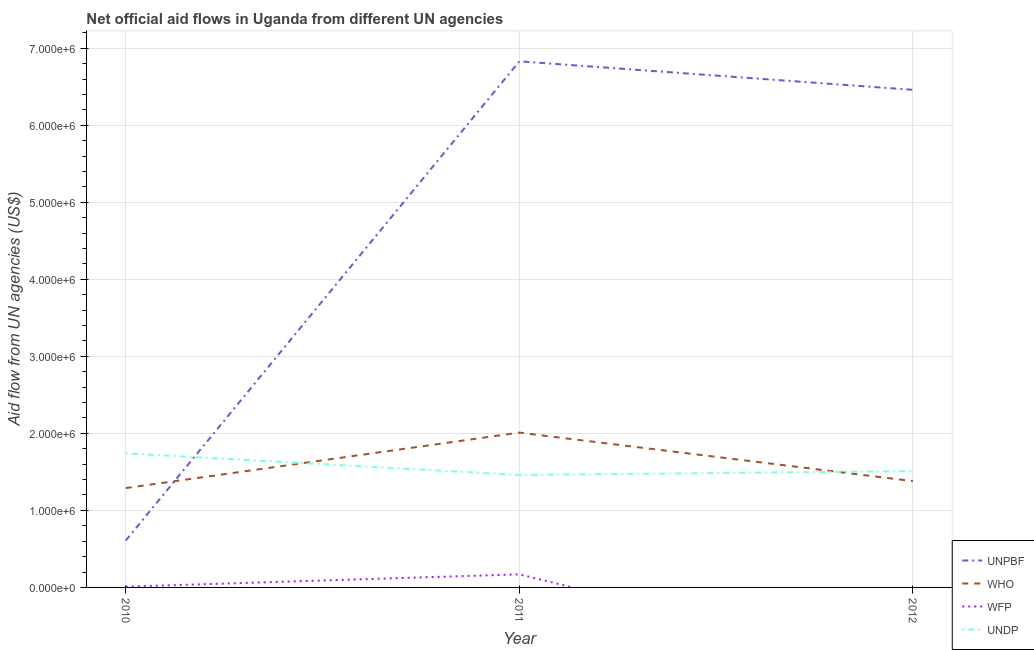How many different coloured lines are there?
Give a very brief answer. 4. Is the number of lines equal to the number of legend labels?
Give a very brief answer. No. What is the amount of aid given by unpbf in 2011?
Make the answer very short. 6.83e+06. Across all years, what is the maximum amount of aid given by wfp?
Your answer should be very brief. 1.70e+05. In which year was the amount of aid given by undp maximum?
Make the answer very short. 2010. What is the total amount of aid given by unpbf in the graph?
Give a very brief answer. 1.39e+07. What is the difference between the amount of aid given by wfp in 2010 and that in 2011?
Make the answer very short. -1.60e+05. What is the difference between the amount of aid given by who in 2011 and the amount of aid given by undp in 2010?
Your answer should be very brief. 2.70e+05. What is the average amount of aid given by unpbf per year?
Provide a succinct answer. 4.63e+06. In the year 2011, what is the difference between the amount of aid given by unpbf and amount of aid given by undp?
Provide a succinct answer. 5.37e+06. In how many years, is the amount of aid given by who greater than 5400000 US$?
Provide a short and direct response. 0. What is the ratio of the amount of aid given by unpbf in 2010 to that in 2011?
Your response must be concise. 0.09. Is the amount of aid given by who in 2011 less than that in 2012?
Offer a very short reply. No. Is the difference between the amount of aid given by who in 2010 and 2011 greater than the difference between the amount of aid given by unpbf in 2010 and 2011?
Your answer should be compact. Yes. What is the difference between the highest and the lowest amount of aid given by undp?
Keep it short and to the point. 2.80e+05. Is the sum of the amount of aid given by who in 2010 and 2012 greater than the maximum amount of aid given by undp across all years?
Offer a terse response. Yes. Is the amount of aid given by undp strictly greater than the amount of aid given by unpbf over the years?
Ensure brevity in your answer.  No. How many lines are there?
Ensure brevity in your answer.  4. How many years are there in the graph?
Your response must be concise. 3. What is the difference between two consecutive major ticks on the Y-axis?
Provide a succinct answer. 1.00e+06. Are the values on the major ticks of Y-axis written in scientific E-notation?
Provide a succinct answer. Yes. Does the graph contain any zero values?
Your response must be concise. Yes. Where does the legend appear in the graph?
Your answer should be compact. Bottom right. What is the title of the graph?
Ensure brevity in your answer.  Net official aid flows in Uganda from different UN agencies. Does "Italy" appear as one of the legend labels in the graph?
Offer a terse response. No. What is the label or title of the Y-axis?
Offer a terse response. Aid flow from UN agencies (US$). What is the Aid flow from UN agencies (US$) of UNPBF in 2010?
Your answer should be very brief. 6.10e+05. What is the Aid flow from UN agencies (US$) in WHO in 2010?
Give a very brief answer. 1.29e+06. What is the Aid flow from UN agencies (US$) in WFP in 2010?
Provide a succinct answer. 10000. What is the Aid flow from UN agencies (US$) of UNDP in 2010?
Give a very brief answer. 1.74e+06. What is the Aid flow from UN agencies (US$) in UNPBF in 2011?
Your answer should be very brief. 6.83e+06. What is the Aid flow from UN agencies (US$) of WHO in 2011?
Your answer should be compact. 2.01e+06. What is the Aid flow from UN agencies (US$) in WFP in 2011?
Ensure brevity in your answer.  1.70e+05. What is the Aid flow from UN agencies (US$) in UNDP in 2011?
Offer a very short reply. 1.46e+06. What is the Aid flow from UN agencies (US$) in UNPBF in 2012?
Offer a terse response. 6.46e+06. What is the Aid flow from UN agencies (US$) of WHO in 2012?
Give a very brief answer. 1.38e+06. What is the Aid flow from UN agencies (US$) of WFP in 2012?
Provide a succinct answer. 0. What is the Aid flow from UN agencies (US$) in UNDP in 2012?
Your answer should be compact. 1.51e+06. Across all years, what is the maximum Aid flow from UN agencies (US$) of UNPBF?
Offer a very short reply. 6.83e+06. Across all years, what is the maximum Aid flow from UN agencies (US$) in WHO?
Offer a very short reply. 2.01e+06. Across all years, what is the maximum Aid flow from UN agencies (US$) in WFP?
Offer a terse response. 1.70e+05. Across all years, what is the maximum Aid flow from UN agencies (US$) in UNDP?
Give a very brief answer. 1.74e+06. Across all years, what is the minimum Aid flow from UN agencies (US$) in UNPBF?
Make the answer very short. 6.10e+05. Across all years, what is the minimum Aid flow from UN agencies (US$) of WHO?
Offer a terse response. 1.29e+06. Across all years, what is the minimum Aid flow from UN agencies (US$) in WFP?
Your answer should be compact. 0. Across all years, what is the minimum Aid flow from UN agencies (US$) in UNDP?
Give a very brief answer. 1.46e+06. What is the total Aid flow from UN agencies (US$) of UNPBF in the graph?
Ensure brevity in your answer.  1.39e+07. What is the total Aid flow from UN agencies (US$) of WHO in the graph?
Give a very brief answer. 4.68e+06. What is the total Aid flow from UN agencies (US$) of WFP in the graph?
Offer a very short reply. 1.80e+05. What is the total Aid flow from UN agencies (US$) in UNDP in the graph?
Provide a succinct answer. 4.71e+06. What is the difference between the Aid flow from UN agencies (US$) of UNPBF in 2010 and that in 2011?
Give a very brief answer. -6.22e+06. What is the difference between the Aid flow from UN agencies (US$) of WHO in 2010 and that in 2011?
Provide a succinct answer. -7.20e+05. What is the difference between the Aid flow from UN agencies (US$) in UNDP in 2010 and that in 2011?
Make the answer very short. 2.80e+05. What is the difference between the Aid flow from UN agencies (US$) in UNPBF in 2010 and that in 2012?
Provide a succinct answer. -5.85e+06. What is the difference between the Aid flow from UN agencies (US$) in UNDP in 2010 and that in 2012?
Offer a terse response. 2.30e+05. What is the difference between the Aid flow from UN agencies (US$) in WHO in 2011 and that in 2012?
Offer a very short reply. 6.30e+05. What is the difference between the Aid flow from UN agencies (US$) of UNDP in 2011 and that in 2012?
Your answer should be compact. -5.00e+04. What is the difference between the Aid flow from UN agencies (US$) of UNPBF in 2010 and the Aid flow from UN agencies (US$) of WHO in 2011?
Your answer should be compact. -1.40e+06. What is the difference between the Aid flow from UN agencies (US$) of UNPBF in 2010 and the Aid flow from UN agencies (US$) of WFP in 2011?
Keep it short and to the point. 4.40e+05. What is the difference between the Aid flow from UN agencies (US$) in UNPBF in 2010 and the Aid flow from UN agencies (US$) in UNDP in 2011?
Your response must be concise. -8.50e+05. What is the difference between the Aid flow from UN agencies (US$) of WHO in 2010 and the Aid flow from UN agencies (US$) of WFP in 2011?
Your response must be concise. 1.12e+06. What is the difference between the Aid flow from UN agencies (US$) of WFP in 2010 and the Aid flow from UN agencies (US$) of UNDP in 2011?
Give a very brief answer. -1.45e+06. What is the difference between the Aid flow from UN agencies (US$) of UNPBF in 2010 and the Aid flow from UN agencies (US$) of WHO in 2012?
Provide a short and direct response. -7.70e+05. What is the difference between the Aid flow from UN agencies (US$) in UNPBF in 2010 and the Aid flow from UN agencies (US$) in UNDP in 2012?
Make the answer very short. -9.00e+05. What is the difference between the Aid flow from UN agencies (US$) of WFP in 2010 and the Aid flow from UN agencies (US$) of UNDP in 2012?
Offer a very short reply. -1.50e+06. What is the difference between the Aid flow from UN agencies (US$) in UNPBF in 2011 and the Aid flow from UN agencies (US$) in WHO in 2012?
Offer a very short reply. 5.45e+06. What is the difference between the Aid flow from UN agencies (US$) of UNPBF in 2011 and the Aid flow from UN agencies (US$) of UNDP in 2012?
Your answer should be very brief. 5.32e+06. What is the difference between the Aid flow from UN agencies (US$) of WFP in 2011 and the Aid flow from UN agencies (US$) of UNDP in 2012?
Your answer should be very brief. -1.34e+06. What is the average Aid flow from UN agencies (US$) of UNPBF per year?
Provide a short and direct response. 4.63e+06. What is the average Aid flow from UN agencies (US$) in WHO per year?
Your answer should be very brief. 1.56e+06. What is the average Aid flow from UN agencies (US$) of WFP per year?
Provide a succinct answer. 6.00e+04. What is the average Aid flow from UN agencies (US$) in UNDP per year?
Provide a short and direct response. 1.57e+06. In the year 2010, what is the difference between the Aid flow from UN agencies (US$) of UNPBF and Aid flow from UN agencies (US$) of WHO?
Provide a succinct answer. -6.80e+05. In the year 2010, what is the difference between the Aid flow from UN agencies (US$) in UNPBF and Aid flow from UN agencies (US$) in WFP?
Offer a terse response. 6.00e+05. In the year 2010, what is the difference between the Aid flow from UN agencies (US$) of UNPBF and Aid flow from UN agencies (US$) of UNDP?
Your answer should be compact. -1.13e+06. In the year 2010, what is the difference between the Aid flow from UN agencies (US$) of WHO and Aid flow from UN agencies (US$) of WFP?
Provide a short and direct response. 1.28e+06. In the year 2010, what is the difference between the Aid flow from UN agencies (US$) in WHO and Aid flow from UN agencies (US$) in UNDP?
Your answer should be very brief. -4.50e+05. In the year 2010, what is the difference between the Aid flow from UN agencies (US$) in WFP and Aid flow from UN agencies (US$) in UNDP?
Your response must be concise. -1.73e+06. In the year 2011, what is the difference between the Aid flow from UN agencies (US$) of UNPBF and Aid flow from UN agencies (US$) of WHO?
Your answer should be compact. 4.82e+06. In the year 2011, what is the difference between the Aid flow from UN agencies (US$) in UNPBF and Aid flow from UN agencies (US$) in WFP?
Offer a terse response. 6.66e+06. In the year 2011, what is the difference between the Aid flow from UN agencies (US$) in UNPBF and Aid flow from UN agencies (US$) in UNDP?
Your response must be concise. 5.37e+06. In the year 2011, what is the difference between the Aid flow from UN agencies (US$) in WHO and Aid flow from UN agencies (US$) in WFP?
Provide a short and direct response. 1.84e+06. In the year 2011, what is the difference between the Aid flow from UN agencies (US$) in WFP and Aid flow from UN agencies (US$) in UNDP?
Your response must be concise. -1.29e+06. In the year 2012, what is the difference between the Aid flow from UN agencies (US$) of UNPBF and Aid flow from UN agencies (US$) of WHO?
Give a very brief answer. 5.08e+06. In the year 2012, what is the difference between the Aid flow from UN agencies (US$) of UNPBF and Aid flow from UN agencies (US$) of UNDP?
Keep it short and to the point. 4.95e+06. What is the ratio of the Aid flow from UN agencies (US$) in UNPBF in 2010 to that in 2011?
Provide a short and direct response. 0.09. What is the ratio of the Aid flow from UN agencies (US$) in WHO in 2010 to that in 2011?
Provide a short and direct response. 0.64. What is the ratio of the Aid flow from UN agencies (US$) in WFP in 2010 to that in 2011?
Offer a terse response. 0.06. What is the ratio of the Aid flow from UN agencies (US$) of UNDP in 2010 to that in 2011?
Keep it short and to the point. 1.19. What is the ratio of the Aid flow from UN agencies (US$) in UNPBF in 2010 to that in 2012?
Provide a short and direct response. 0.09. What is the ratio of the Aid flow from UN agencies (US$) in WHO in 2010 to that in 2012?
Ensure brevity in your answer.  0.93. What is the ratio of the Aid flow from UN agencies (US$) in UNDP in 2010 to that in 2012?
Your answer should be very brief. 1.15. What is the ratio of the Aid flow from UN agencies (US$) of UNPBF in 2011 to that in 2012?
Your answer should be compact. 1.06. What is the ratio of the Aid flow from UN agencies (US$) of WHO in 2011 to that in 2012?
Ensure brevity in your answer.  1.46. What is the ratio of the Aid flow from UN agencies (US$) of UNDP in 2011 to that in 2012?
Keep it short and to the point. 0.97. What is the difference between the highest and the second highest Aid flow from UN agencies (US$) in WHO?
Provide a succinct answer. 6.30e+05. What is the difference between the highest and the second highest Aid flow from UN agencies (US$) in UNDP?
Make the answer very short. 2.30e+05. What is the difference between the highest and the lowest Aid flow from UN agencies (US$) in UNPBF?
Make the answer very short. 6.22e+06. What is the difference between the highest and the lowest Aid flow from UN agencies (US$) of WHO?
Your response must be concise. 7.20e+05. What is the difference between the highest and the lowest Aid flow from UN agencies (US$) of WFP?
Ensure brevity in your answer.  1.70e+05. 